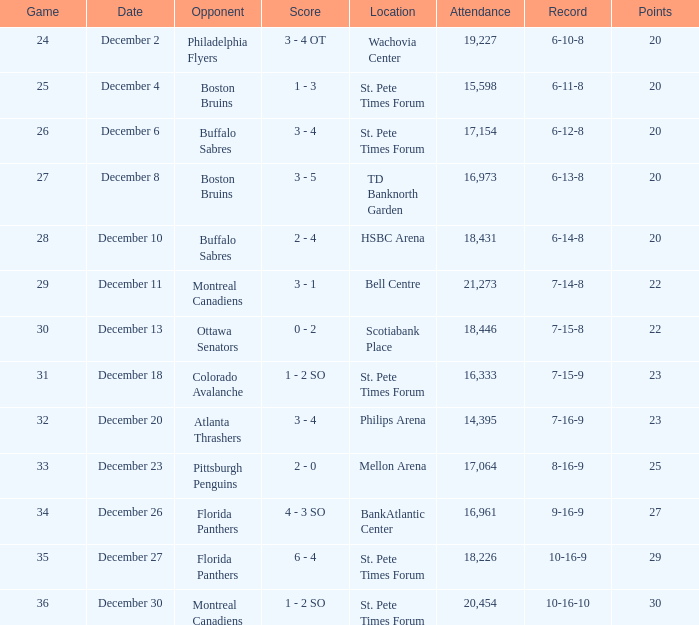What is the location of the game with a 6-11-8 record? St. Pete Times Forum. 